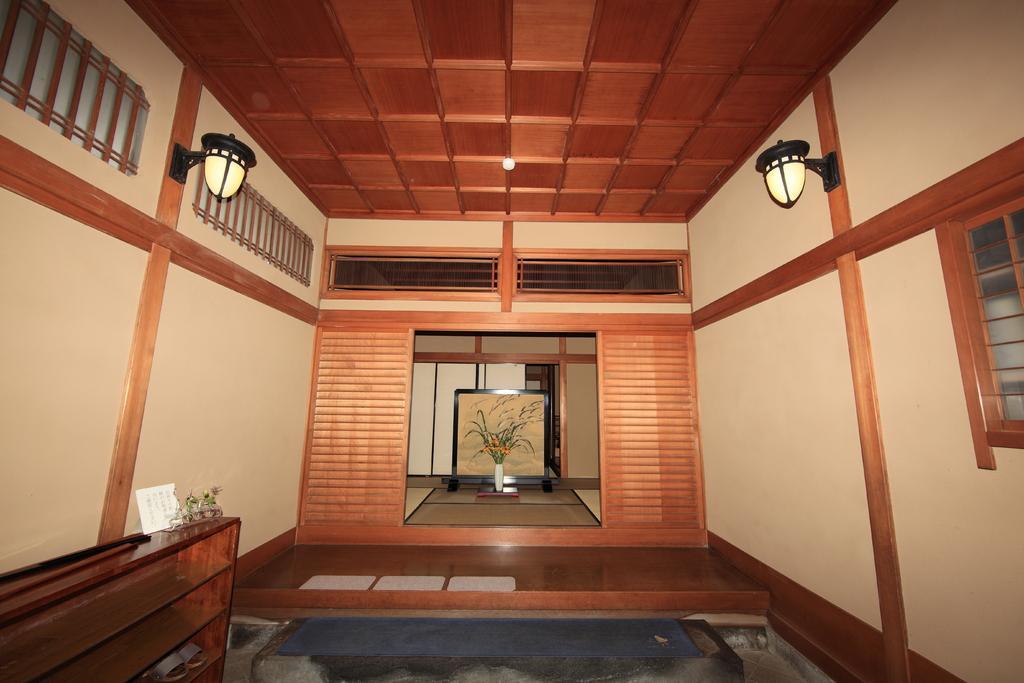Can you describe this image briefly? In the foreground of this image, at the bottom, there is a stair. On the left, there is a wooden object. On which there are few objects. On either side, there are lamps on the walls. In the background, there is a wooden wall entrance, a flower vase, wall, a board like an object and the floor. 